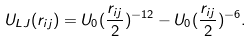<formula> <loc_0><loc_0><loc_500><loc_500>U _ { L J } ( r _ { i j } ) = U _ { 0 } ( \frac { r _ { i j } } { 2 } ) ^ { - 1 2 } - U _ { 0 } ( \frac { r _ { i j } } { 2 } ) ^ { - 6 } .</formula> 